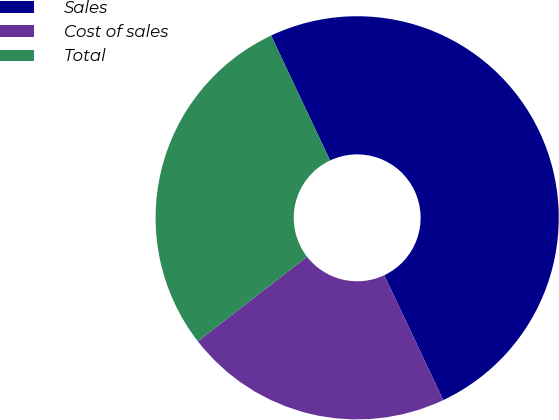<chart> <loc_0><loc_0><loc_500><loc_500><pie_chart><fcel>Sales<fcel>Cost of sales<fcel>Total<nl><fcel>50.0%<fcel>21.53%<fcel>28.47%<nl></chart> 